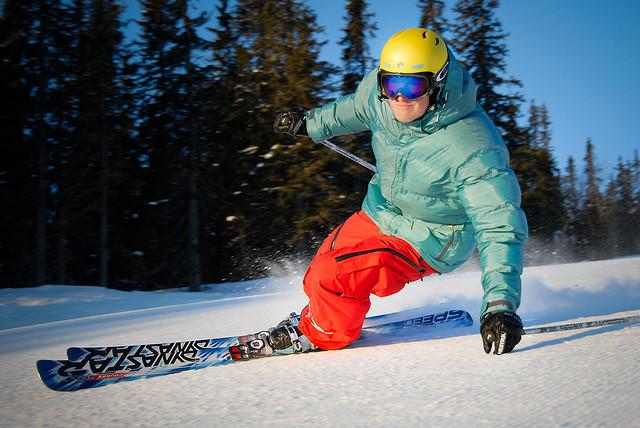What does the man have on his feet?
Answer briefly. Skis. What is the man doing?
Write a very short answer. Skiing. Is the man getting ready to fall into the snow?
Quick response, please. No. Does the person look like a child?
Concise answer only. No. What color are the pants?
Give a very brief answer. Red. 